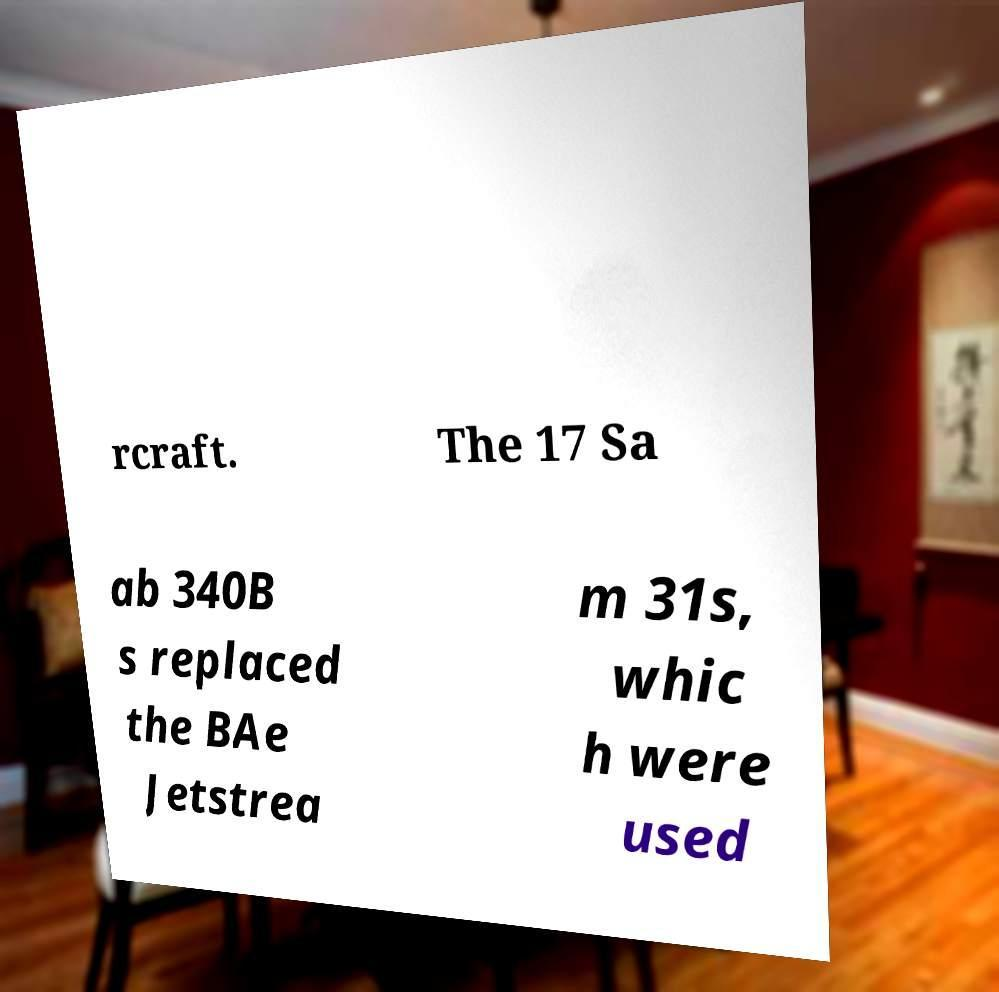Can you read and provide the text displayed in the image?This photo seems to have some interesting text. Can you extract and type it out for me? rcraft. The 17 Sa ab 340B s replaced the BAe Jetstrea m 31s, whic h were used 